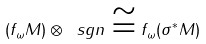<formula> <loc_0><loc_0><loc_500><loc_500>( f _ { \omega } M ) \otimes \ s g n \cong f _ { \omega } ( \sigma ^ { * } M )</formula> 